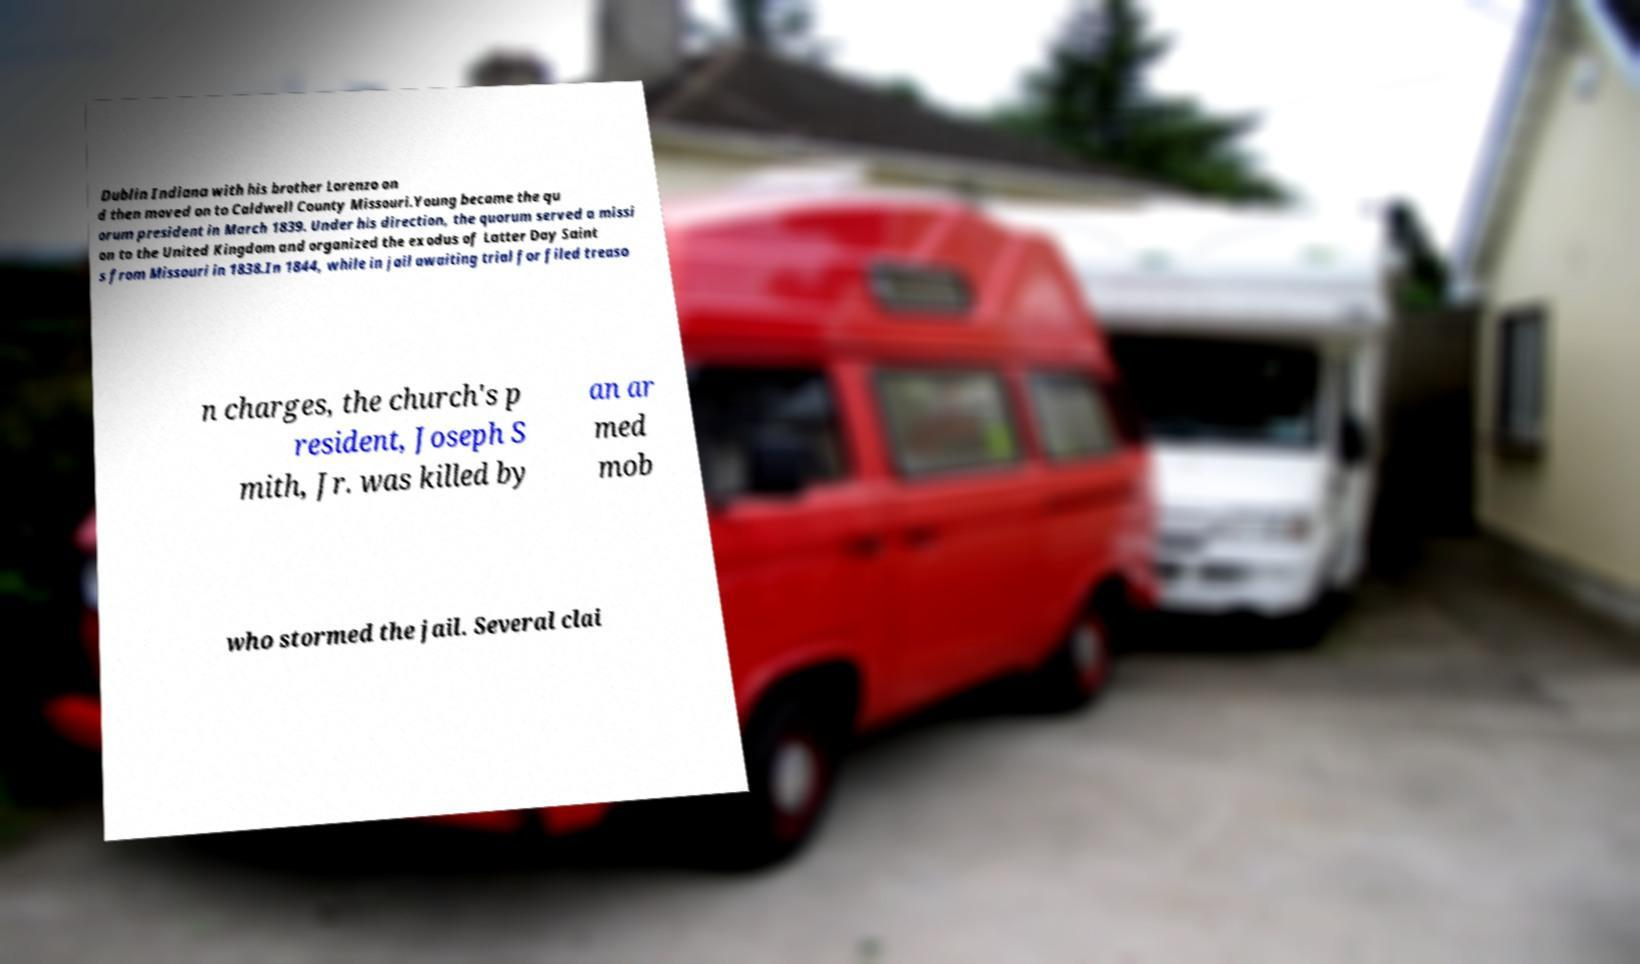Can you accurately transcribe the text from the provided image for me? Dublin Indiana with his brother Lorenzo an d then moved on to Caldwell County Missouri.Young became the qu orum president in March 1839. Under his direction, the quorum served a missi on to the United Kingdom and organized the exodus of Latter Day Saint s from Missouri in 1838.In 1844, while in jail awaiting trial for filed treaso n charges, the church's p resident, Joseph S mith, Jr. was killed by an ar med mob who stormed the jail. Several clai 